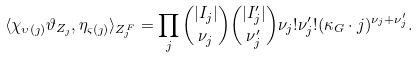<formula> <loc_0><loc_0><loc_500><loc_500>\langle \chi _ { \upsilon ( \jmath ) } \vartheta _ { Z _ { \jmath } } , \eta _ { \varsigma ( \jmath ) } \rangle _ { Z _ { \jmath } ^ { F } } = \prod _ { j } { | I _ { j } | \choose \nu _ { j } } { | I _ { j } ^ { \prime } | \choose \nu _ { j } ^ { \prime } } \nu _ { j } ! \nu _ { j } ^ { \prime } ! ( \kappa _ { G } \cdot j ) ^ { \nu _ { j } + \nu _ { j } ^ { \prime } } .</formula> 